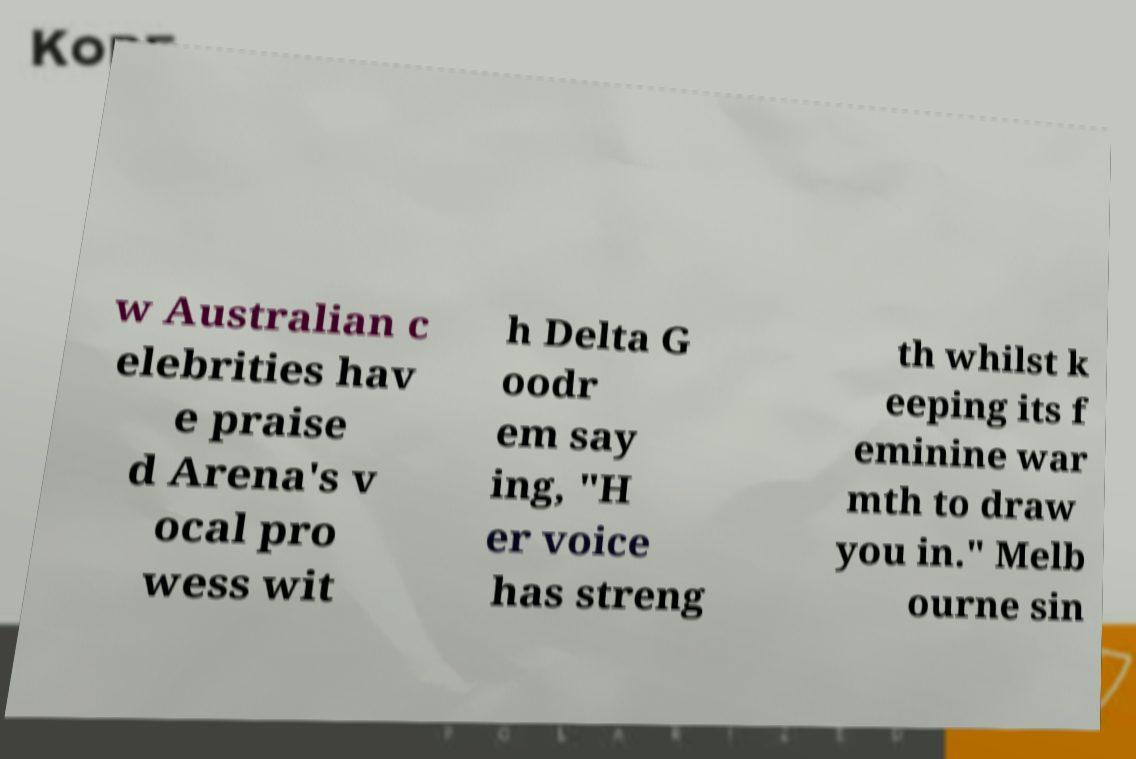I need the written content from this picture converted into text. Can you do that? w Australian c elebrities hav e praise d Arena's v ocal pro wess wit h Delta G oodr em say ing, "H er voice has streng th whilst k eeping its f eminine war mth to draw you in." Melb ourne sin 